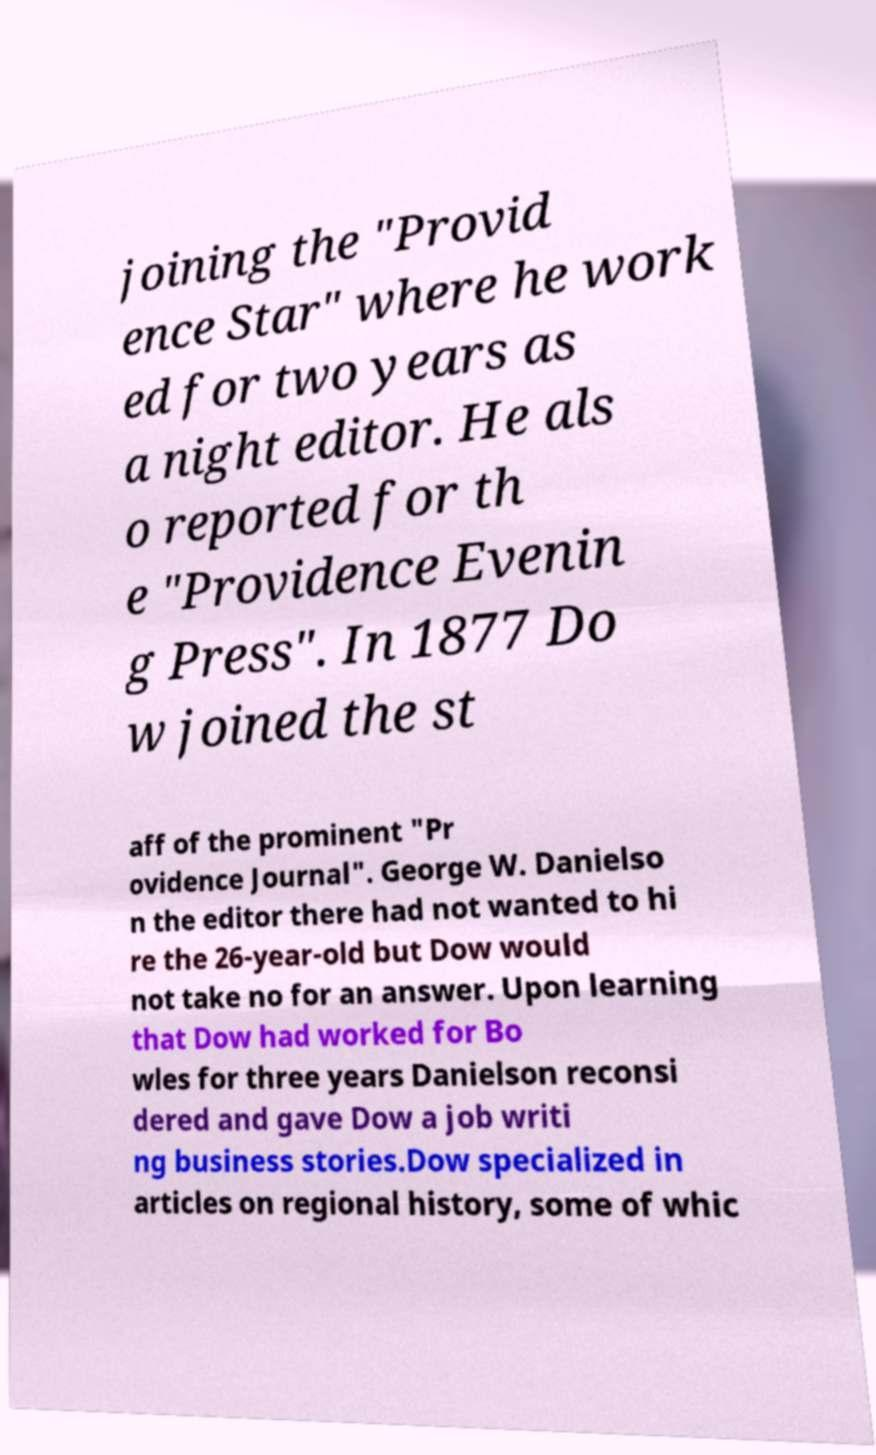I need the written content from this picture converted into text. Can you do that? joining the "Provid ence Star" where he work ed for two years as a night editor. He als o reported for th e "Providence Evenin g Press". In 1877 Do w joined the st aff of the prominent "Pr ovidence Journal". George W. Danielso n the editor there had not wanted to hi re the 26-year-old but Dow would not take no for an answer. Upon learning that Dow had worked for Bo wles for three years Danielson reconsi dered and gave Dow a job writi ng business stories.Dow specialized in articles on regional history, some of whic 